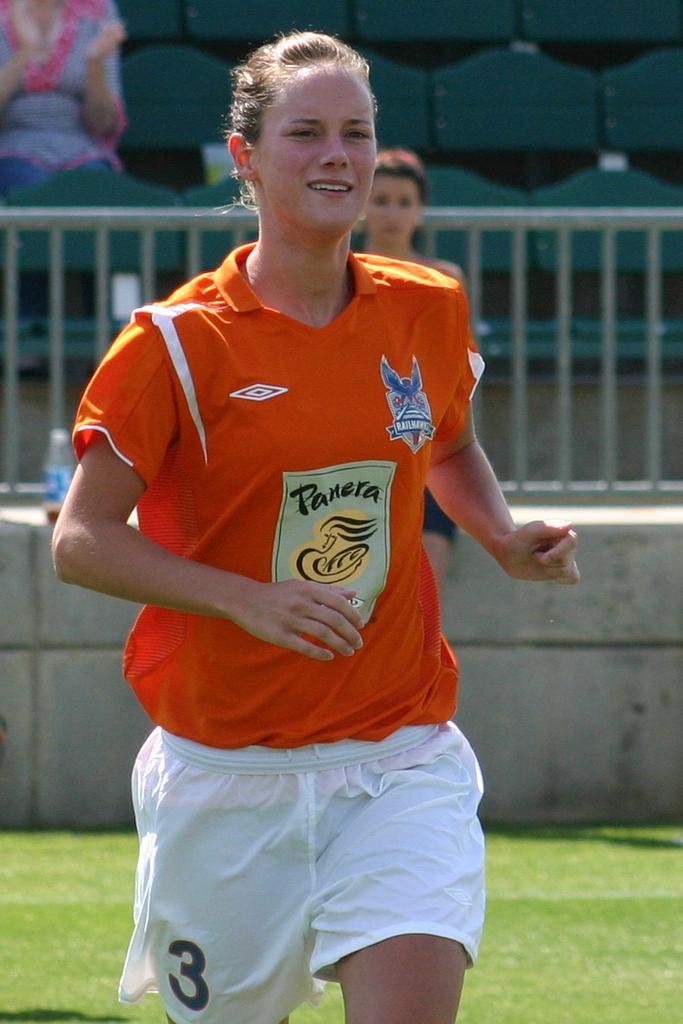<image>
Describe the image concisely. An athlete is wearing a shirt sponsored by Panera Bread. 